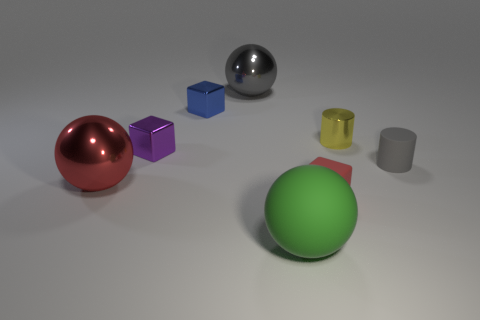Subtract all small shiny cubes. How many cubes are left? 1 Add 1 small matte objects. How many objects exist? 9 Subtract 0 brown blocks. How many objects are left? 8 Subtract all balls. How many objects are left? 5 Subtract 2 cylinders. How many cylinders are left? 0 Subtract all gray cubes. Subtract all yellow cylinders. How many cubes are left? 3 Subtract all green matte balls. Subtract all blue metal blocks. How many objects are left? 6 Add 3 rubber cubes. How many rubber cubes are left? 4 Add 7 blue metal cubes. How many blue metal cubes exist? 8 Subtract all yellow cylinders. How many cylinders are left? 1 